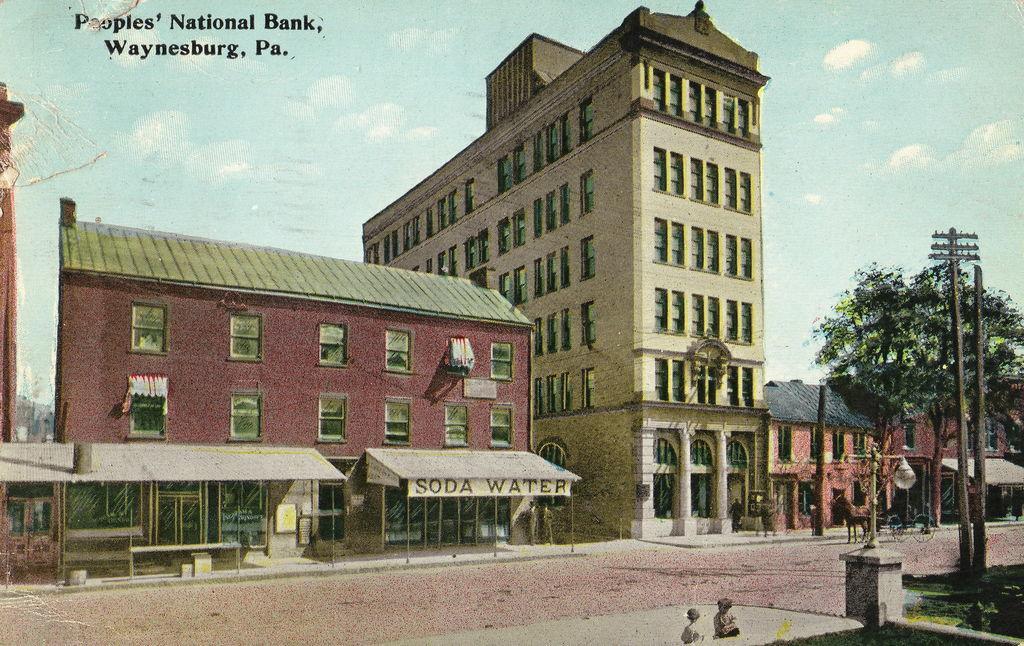How would you summarize this image in a sentence or two? This is an edited image in which there are buildings, there is an animal, there are persons, trees, poles and the sky is cloudy and there is some text written on the top of the image and in front of the building there is a tent with some text written on it. 